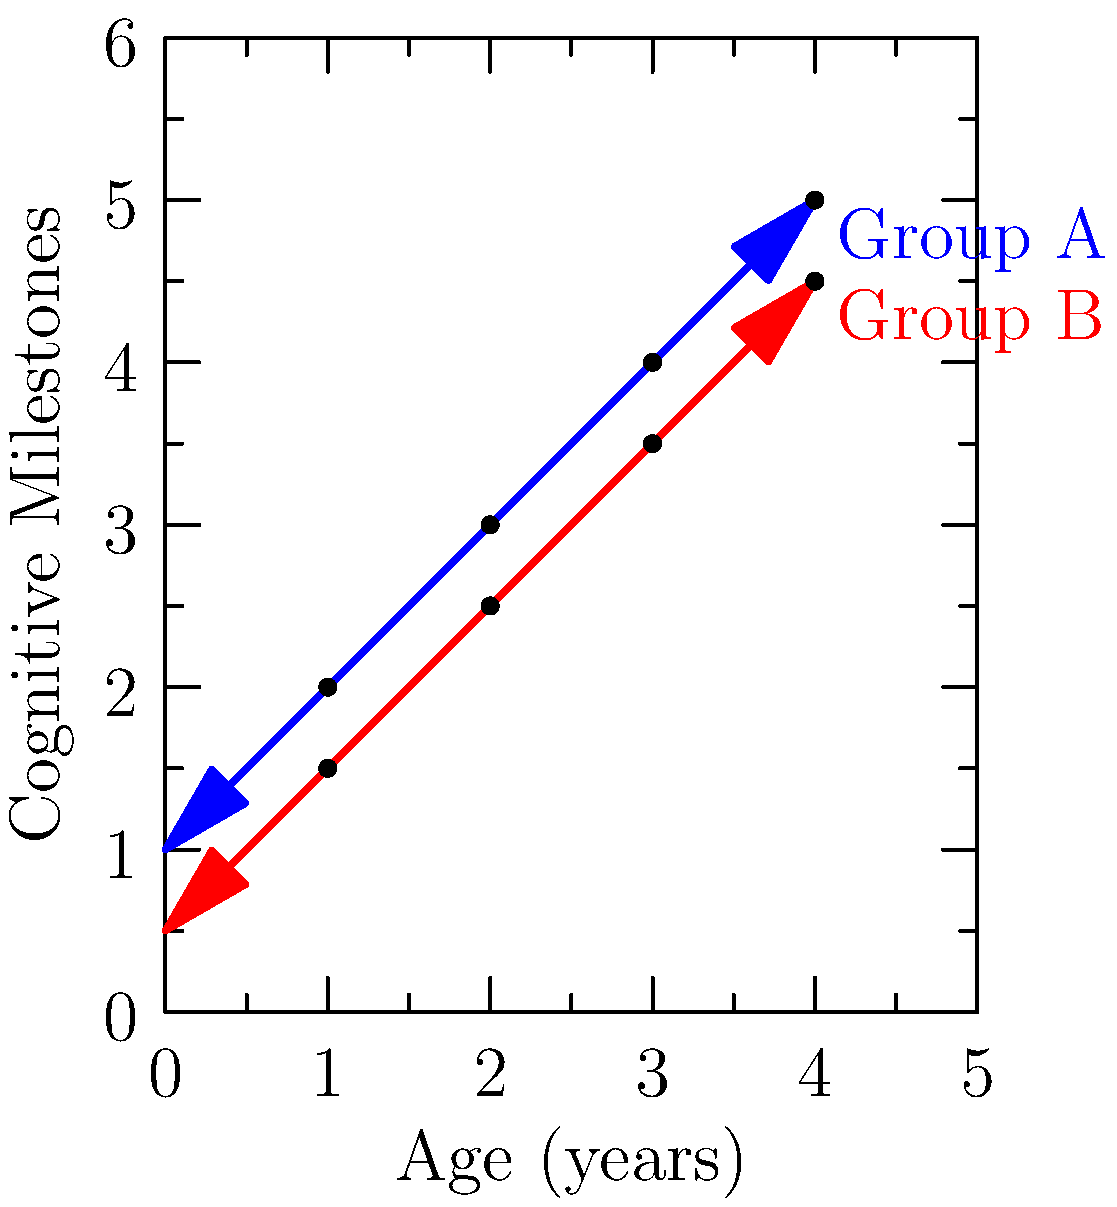Based on the developmental chart comparing cognitive milestones across age groups, at what age does Group A show the most significant advancement compared to Group B? To determine at which age Group A shows the most significant advancement compared to Group B, we need to analyze the difference between the two groups at each age point:

1. At age 1: Group A is at 2, Group B is at 1.5. Difference: 0.5
2. At age 2: Group A is at 3, Group B is at 2.5. Difference: 0.5
3. At age 3: Group A is at 4, Group B is at 3.5. Difference: 0.5
4. At age 4: Group A is at 5, Group B is at 4.5. Difference: 0.5

The difference between Group A and Group B remains constant at 0.5 units across all age points. However, the question asks for the most significant advancement, which can be interpreted as the largest relative difference.

To find the relative difference, we can calculate the ratio of Group A to Group B at each age:

1. At age 1: 2 / 1.5 ≈ 1.33
2. At age 2: 3 / 2.5 = 1.2
3. At age 3: 4 / 3.5 ≈ 1.14
4. At age 4: 5 / 4.5 ≈ 1.11

The largest relative difference is at age 1, where Group A's score is about 1.33 times that of Group B. This indicates that the most significant advancement of Group A compared to Group B occurs at age 1.
Answer: 1 year 